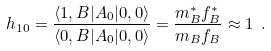Convert formula to latex. <formula><loc_0><loc_0><loc_500><loc_500>h _ { 1 0 } = \frac { \langle 1 , B | A _ { 0 } | 0 , 0 \rangle } { \langle 0 , B | A _ { 0 } | 0 , 0 \rangle } = \frac { m _ { B } ^ { * } f _ { B } ^ { * } } { m _ { B } f _ { B } } \approx 1 \ .</formula> 